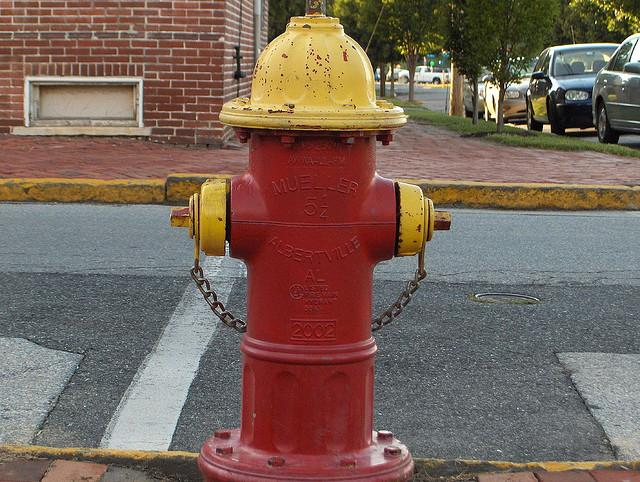The red color of fire hydrant represents what? fire 